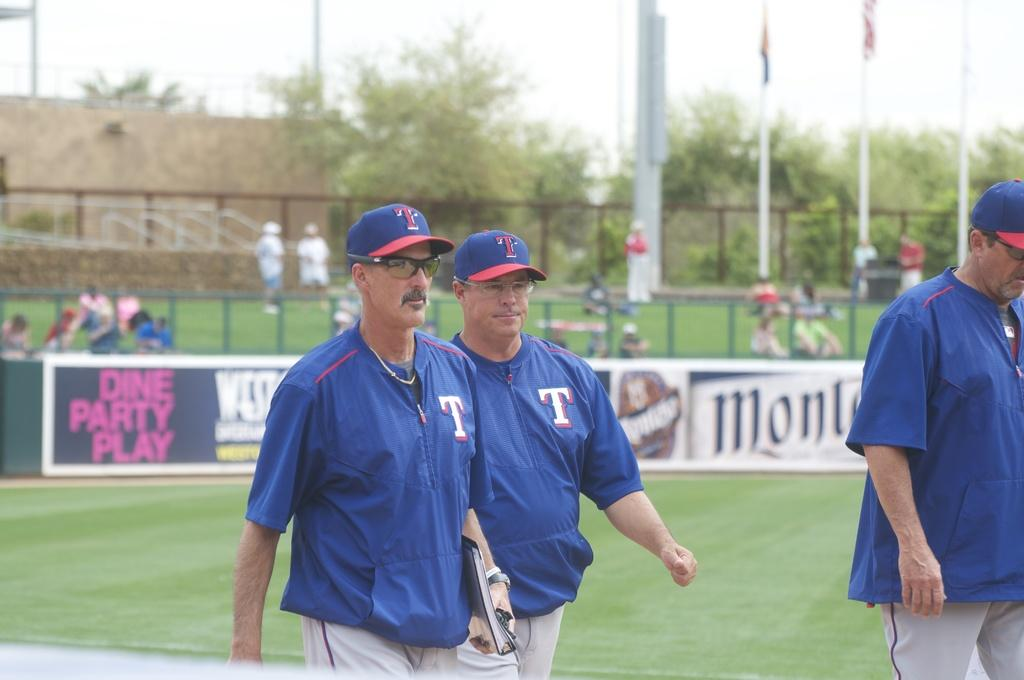<image>
Summarize the visual content of the image. Several people wearing hats with a red "T" on them walk across the field. 